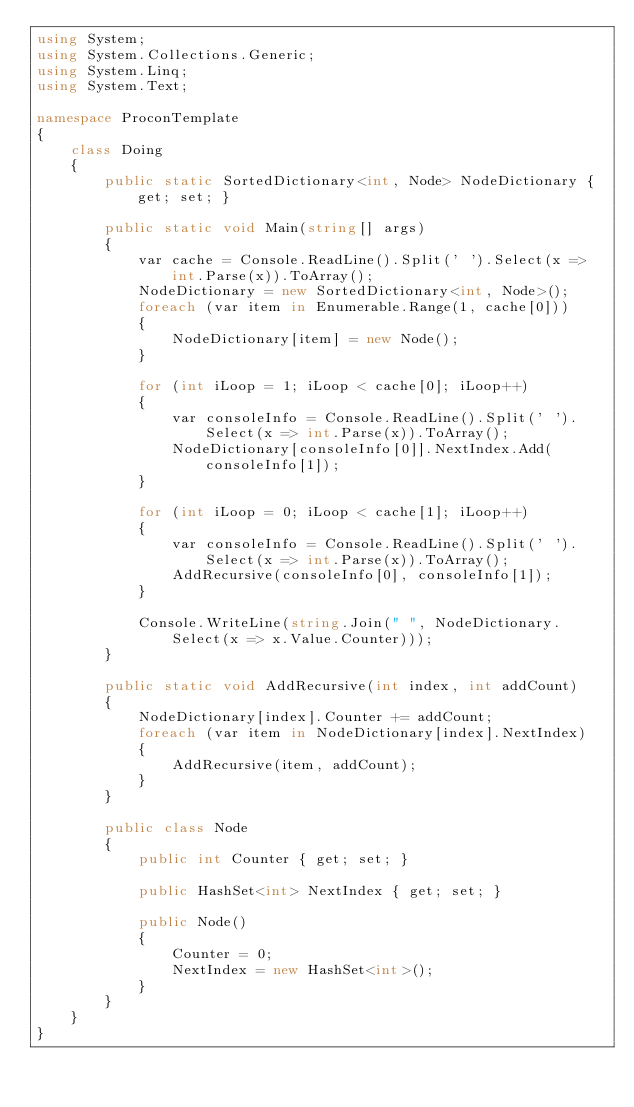Convert code to text. <code><loc_0><loc_0><loc_500><loc_500><_C#_>using System;
using System.Collections.Generic;
using System.Linq;
using System.Text;

namespace ProconTemplate
{
    class Doing
    {
        public static SortedDictionary<int, Node> NodeDictionary { get; set; }

        public static void Main(string[] args)
        {
            var cache = Console.ReadLine().Split(' ').Select(x => int.Parse(x)).ToArray();
            NodeDictionary = new SortedDictionary<int, Node>();
            foreach (var item in Enumerable.Range(1, cache[0]))
            {
                NodeDictionary[item] = new Node();
            }

            for (int iLoop = 1; iLoop < cache[0]; iLoop++)
            {
                var consoleInfo = Console.ReadLine().Split(' ').Select(x => int.Parse(x)).ToArray();
                NodeDictionary[consoleInfo[0]].NextIndex.Add(consoleInfo[1]);
            }

            for (int iLoop = 0; iLoop < cache[1]; iLoop++)
            {
                var consoleInfo = Console.ReadLine().Split(' ').Select(x => int.Parse(x)).ToArray();
                AddRecursive(consoleInfo[0], consoleInfo[1]);
            }

            Console.WriteLine(string.Join(" ", NodeDictionary.Select(x => x.Value.Counter)));
        }

        public static void AddRecursive(int index, int addCount)
        {
            NodeDictionary[index].Counter += addCount;
            foreach (var item in NodeDictionary[index].NextIndex)
            {
                AddRecursive(item, addCount);
            }
        }

        public class Node
        {
            public int Counter { get; set; }

            public HashSet<int> NextIndex { get; set; }

            public Node()
            {
                Counter = 0;
                NextIndex = new HashSet<int>();
            }
        }
    }
}
</code> 